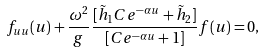Convert formula to latex. <formula><loc_0><loc_0><loc_500><loc_500>f _ { u u } ( u ) + \frac { \omega ^ { 2 } } { g } \frac { [ \tilde { h } _ { 1 } C e ^ { - \alpha u } + \tilde { h } _ { 2 } ] } { [ C e ^ { - \alpha u } + 1 ] } f ( u ) = 0 ,</formula> 